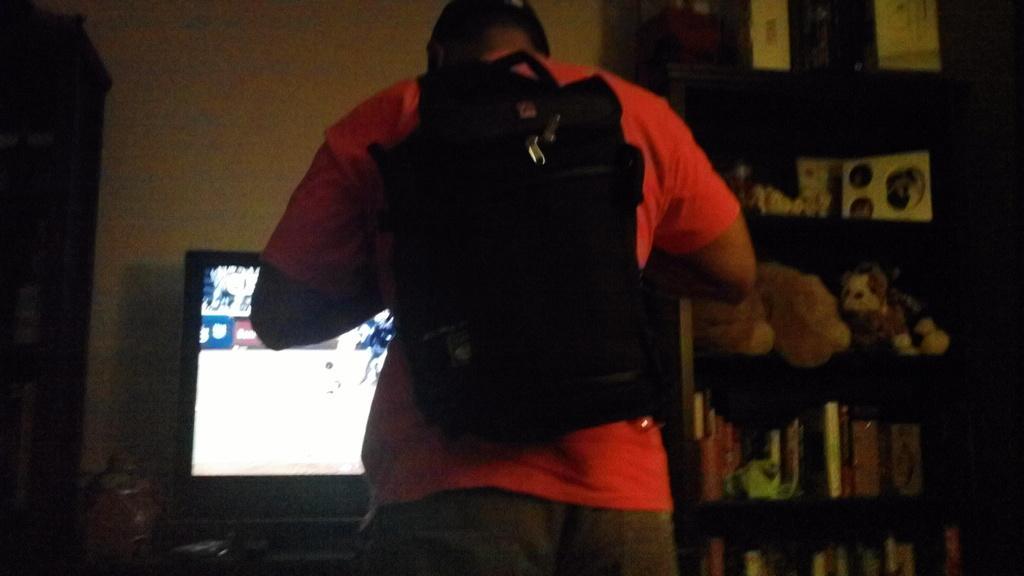Could you give a brief overview of what you see in this image? In the image there is a person in the foreground, behind the person there is a television and on the right side there is a cupboard, there are many objects kept on the shelves of the cupboards, in the background there is a wall. 